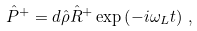Convert formula to latex. <formula><loc_0><loc_0><loc_500><loc_500>\hat { P } ^ { + } = { d } \hat { \rho } \hat { R } ^ { + } \exp \left ( - i \omega _ { L } t \right ) \, ,</formula> 